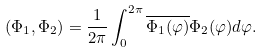Convert formula to latex. <formula><loc_0><loc_0><loc_500><loc_500>( \Phi _ { 1 } , \Phi _ { 2 } ) = \frac { 1 } { 2 \pi } \int _ { 0 } ^ { 2 \pi } \overline { \Phi _ { 1 } ( \varphi ) } \Phi _ { 2 } ( \varphi ) d \varphi .</formula> 